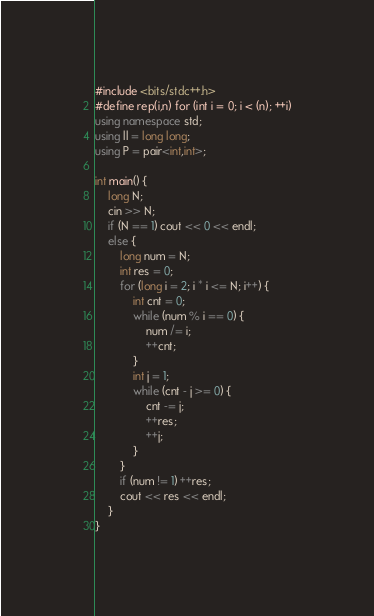<code> <loc_0><loc_0><loc_500><loc_500><_C++_>#include <bits/stdc++.h>
#define rep(i,n) for (int i = 0; i < (n); ++i)
using namespace std;
using ll = long long;
using P = pair<int,int>;

int main() {
    long N;
    cin >> N;
    if (N == 1) cout << 0 << endl;
    else {
        long num = N;
        int res = 0;
        for (long i = 2; i * i <= N; i++) {
            int cnt = 0;
            while (num % i == 0) {
                num /= i;
                ++cnt;
            }
            int j = 1;
            while (cnt - j >= 0) {
                cnt -= j;
                ++res;
                ++j;
            }
        }
        if (num != 1) ++res;
        cout << res << endl;
    }
}

</code> 